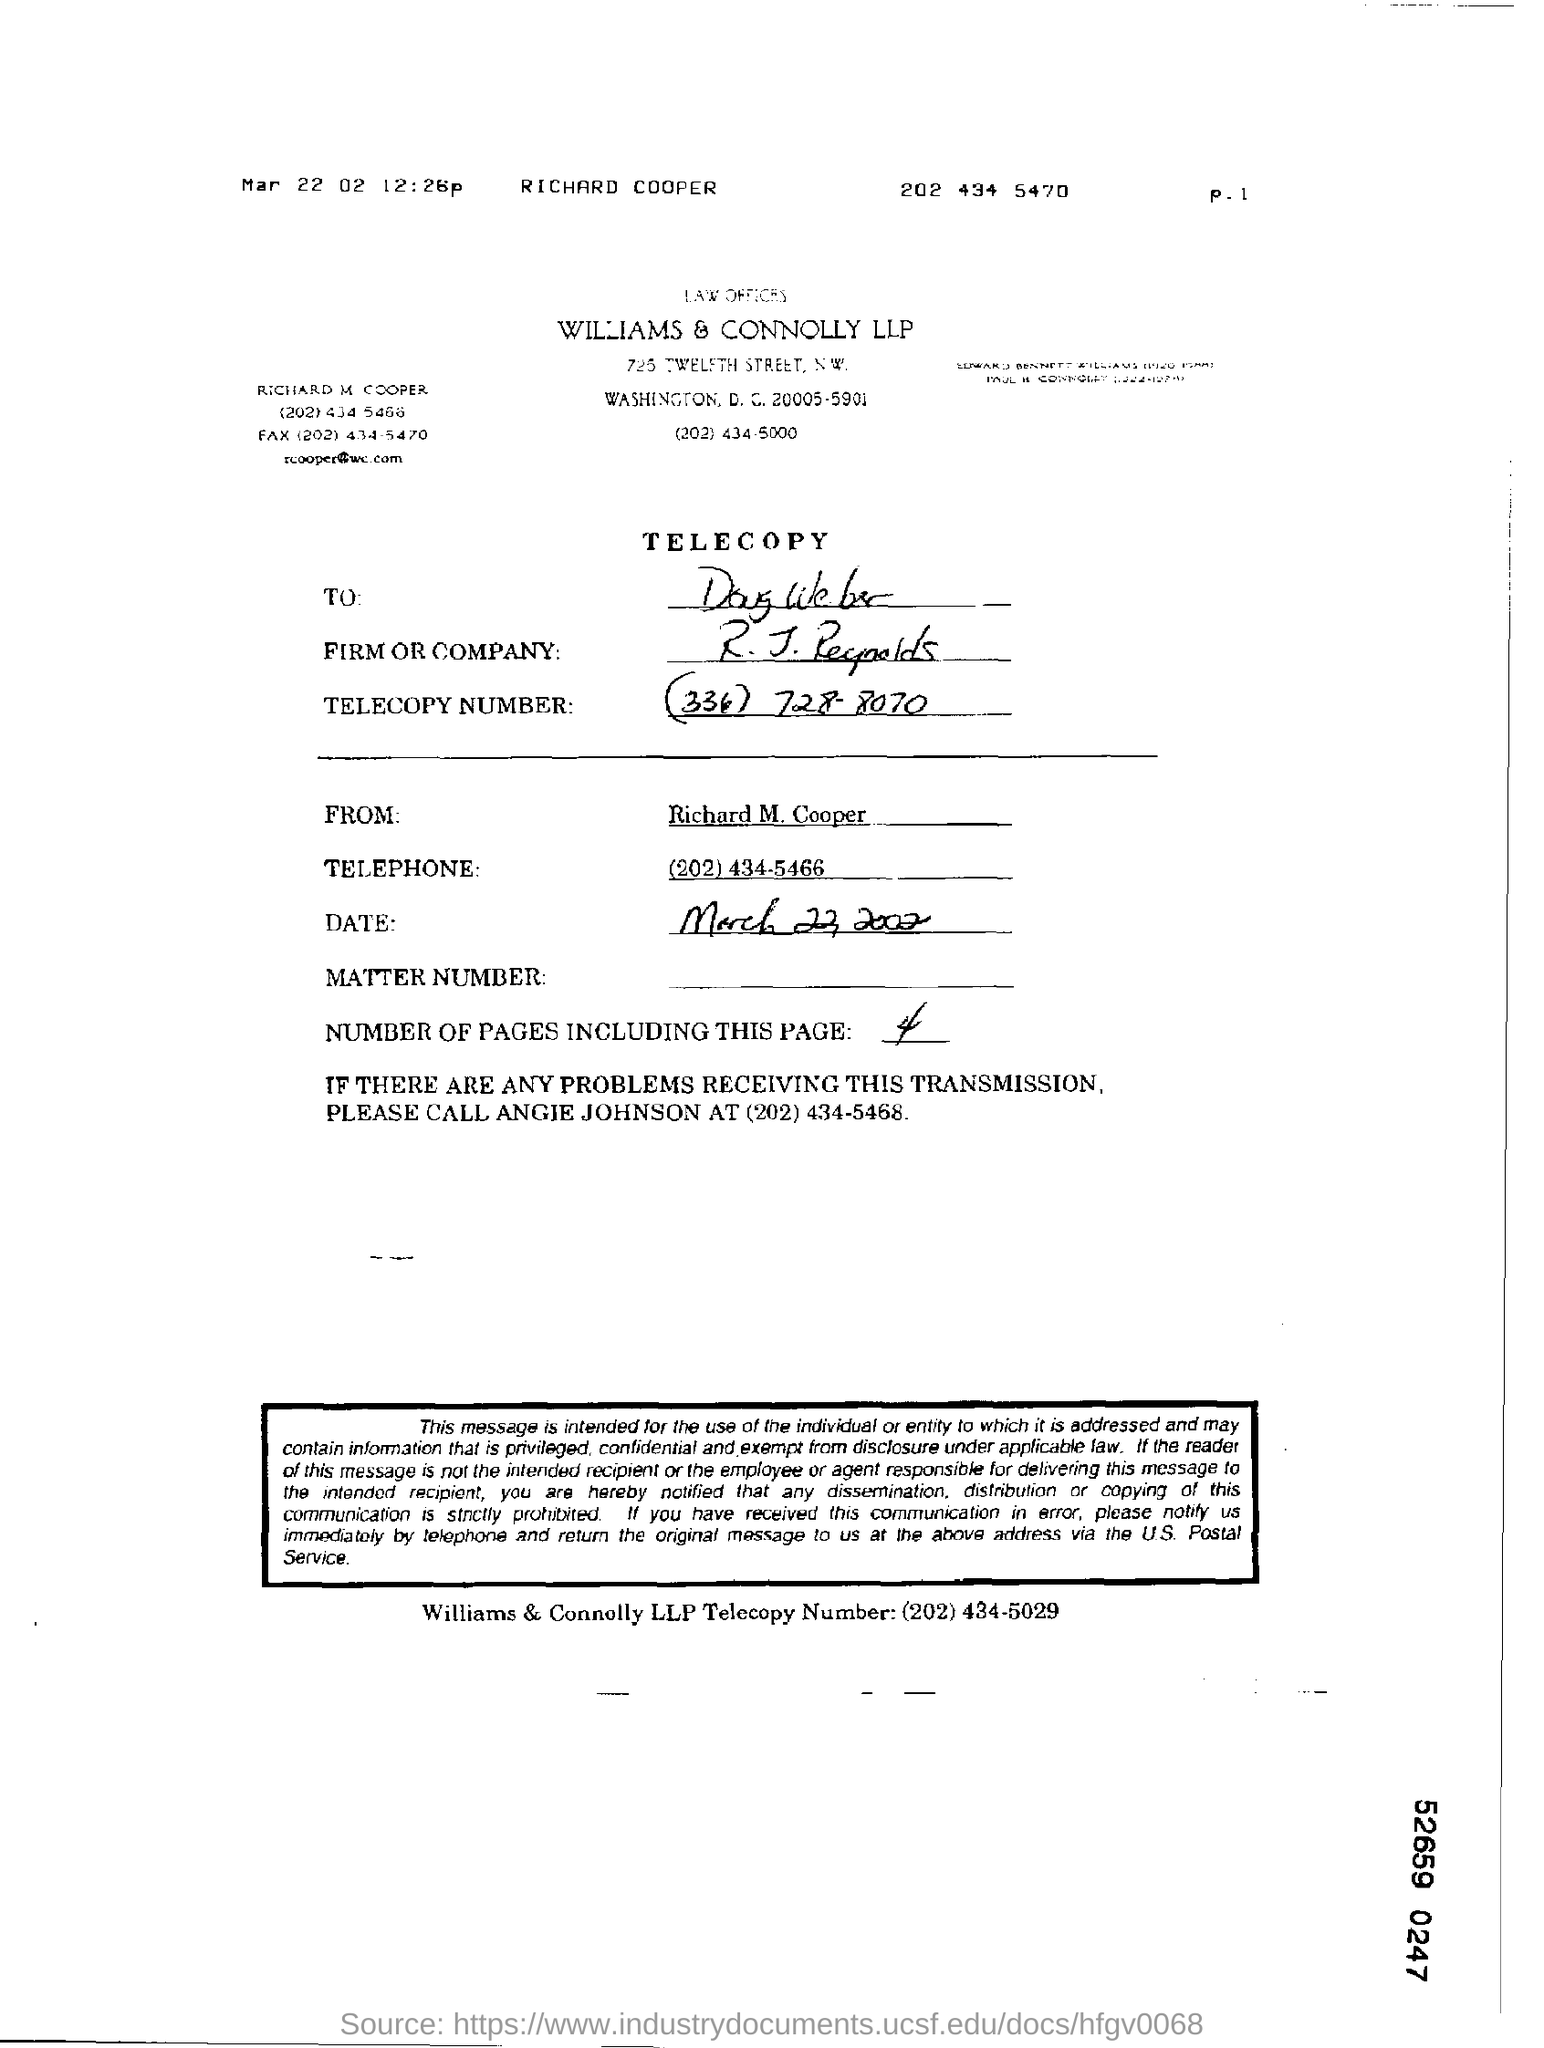To Whom is this Telecopy addressed to?
Make the answer very short. Doug Weber. Who is this Telecopy From?
Your answer should be very brief. Richard M. Cooper. What is the Telecopy Number?
Make the answer very short. (334) 728-8070. What are the number of pages including this page?
Offer a very short reply. 4. 